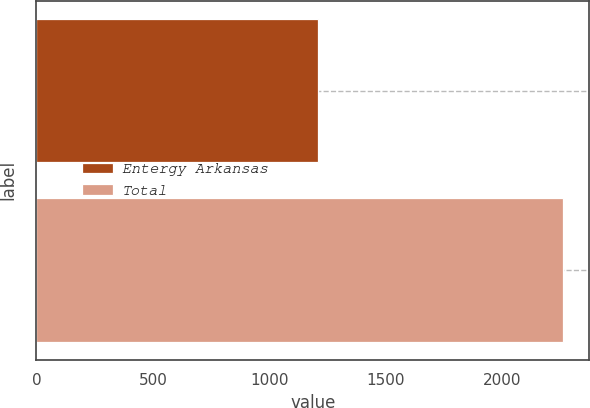Convert chart to OTSL. <chart><loc_0><loc_0><loc_500><loc_500><bar_chart><fcel>Entergy Arkansas<fcel>Total<nl><fcel>1207<fcel>2259<nl></chart> 